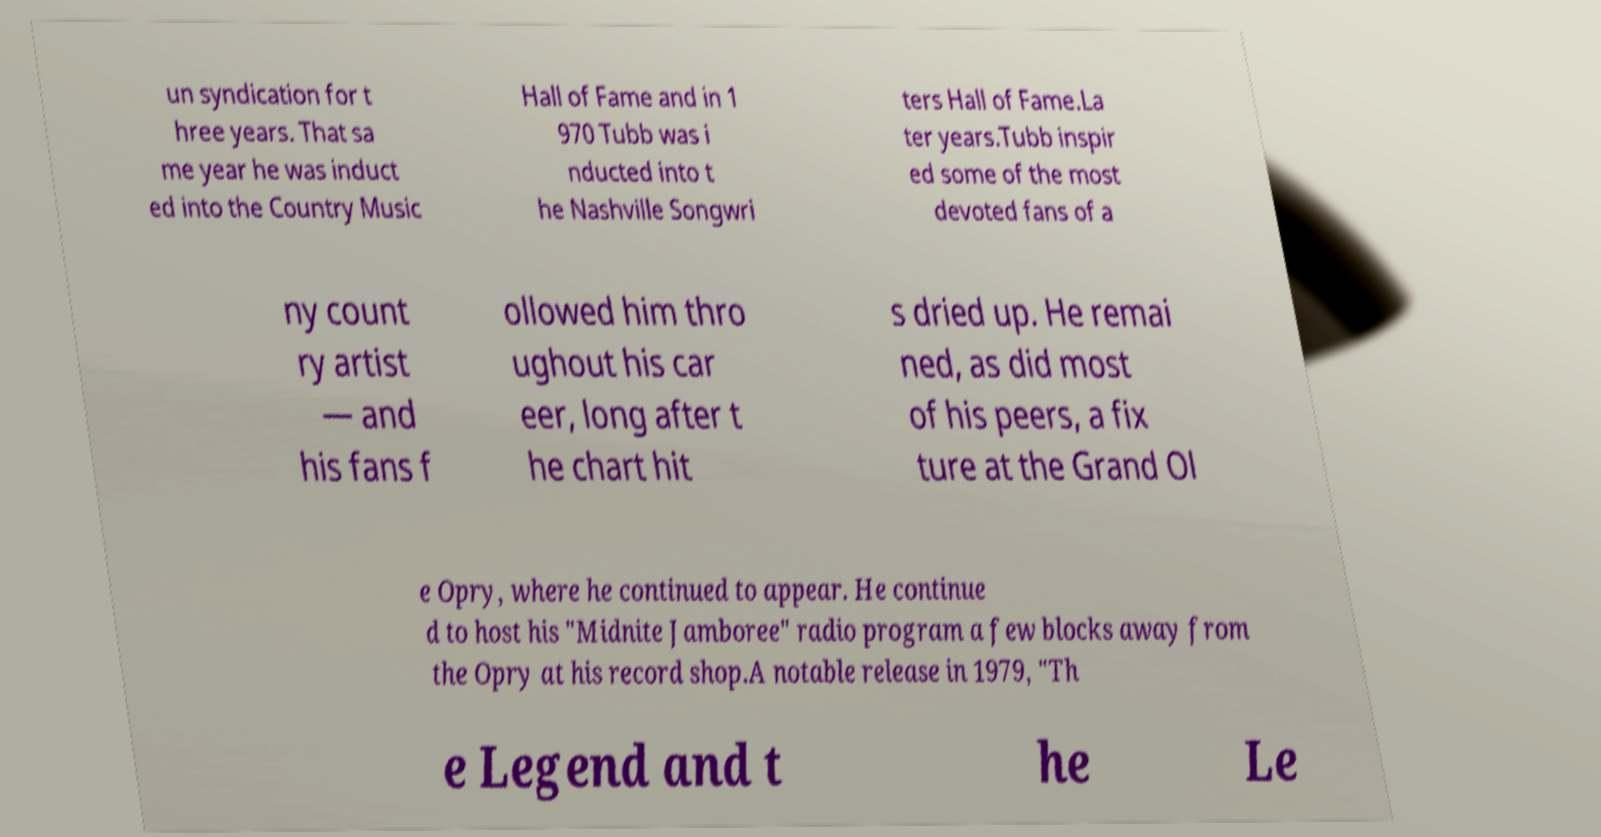Can you read and provide the text displayed in the image?This photo seems to have some interesting text. Can you extract and type it out for me? un syndication for t hree years. That sa me year he was induct ed into the Country Music Hall of Fame and in 1 970 Tubb was i nducted into t he Nashville Songwri ters Hall of Fame.La ter years.Tubb inspir ed some of the most devoted fans of a ny count ry artist — and his fans f ollowed him thro ughout his car eer, long after t he chart hit s dried up. He remai ned, as did most of his peers, a fix ture at the Grand Ol e Opry, where he continued to appear. He continue d to host his "Midnite Jamboree" radio program a few blocks away from the Opry at his record shop.A notable release in 1979, "Th e Legend and t he Le 